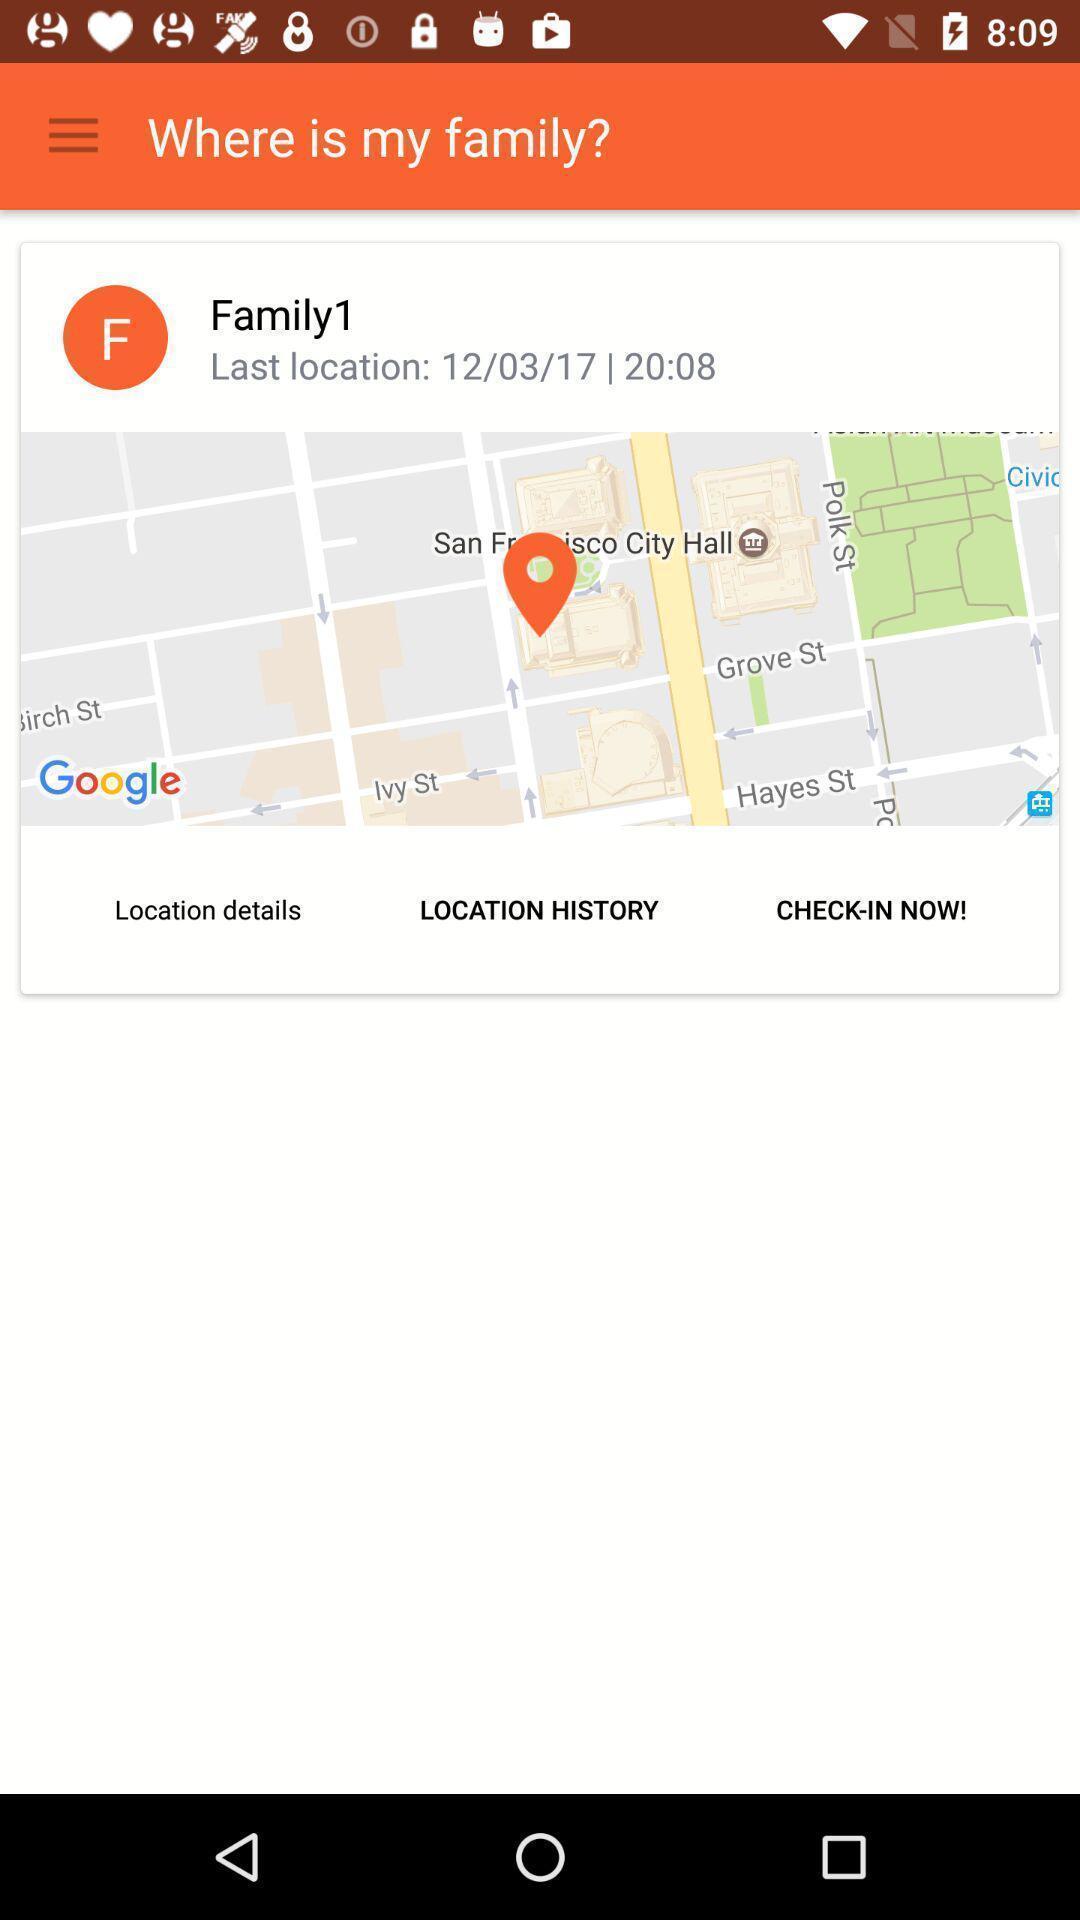What is the overall content of this screenshot? Showing last location of family with date. 